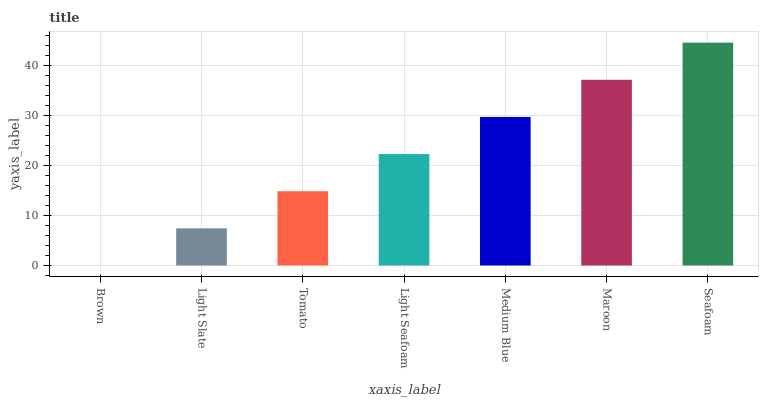Is Brown the minimum?
Answer yes or no. Yes. Is Seafoam the maximum?
Answer yes or no. Yes. Is Light Slate the minimum?
Answer yes or no. No. Is Light Slate the maximum?
Answer yes or no. No. Is Light Slate greater than Brown?
Answer yes or no. Yes. Is Brown less than Light Slate?
Answer yes or no. Yes. Is Brown greater than Light Slate?
Answer yes or no. No. Is Light Slate less than Brown?
Answer yes or no. No. Is Light Seafoam the high median?
Answer yes or no. Yes. Is Light Seafoam the low median?
Answer yes or no. Yes. Is Seafoam the high median?
Answer yes or no. No. Is Maroon the low median?
Answer yes or no. No. 